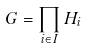Convert formula to latex. <formula><loc_0><loc_0><loc_500><loc_500>G = \prod _ { i \in I } H _ { i }</formula> 